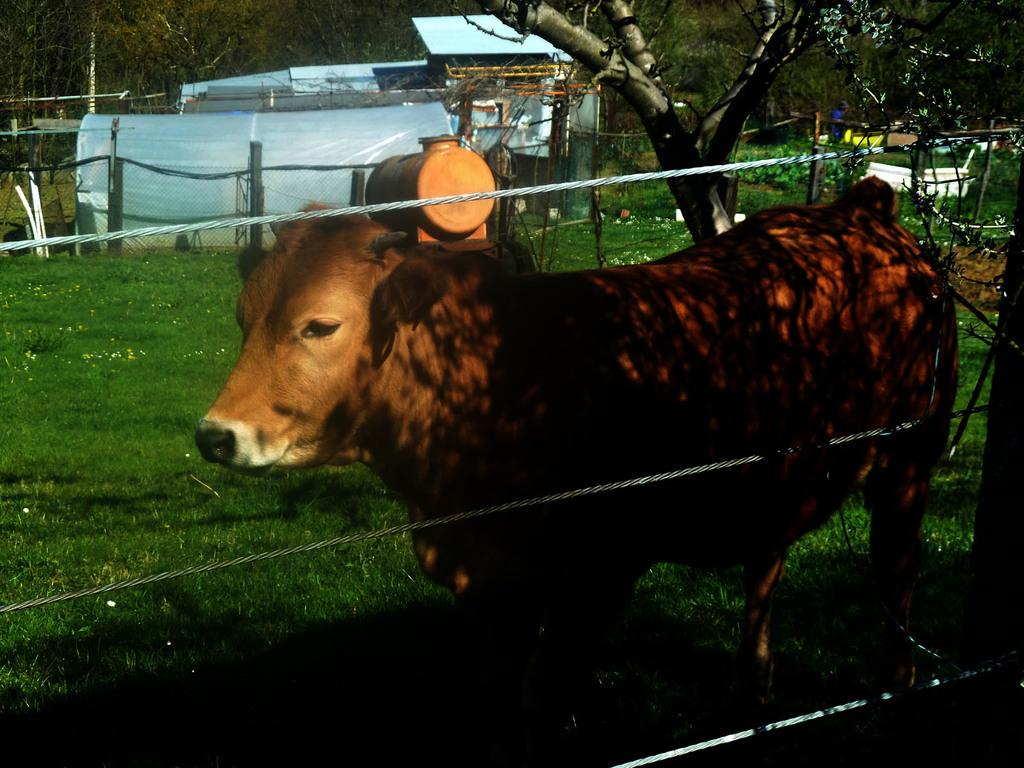What type of animal can be seen in the image? There is an animal standing on the ground in the image. What can be seen in the background of the image? There is grass, a fence, trees, and other objects on the ground in the background of the image. What story or account is the animal telling in the image? There is no indication in the image that the animal is telling a story or account; it is simply standing on the ground. How many ants can be seen in the image? There are no ants present in the image. 